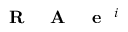<formula> <loc_0><loc_0><loc_500><loc_500>R A e ^ { i }</formula> 